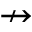<formula> <loc_0><loc_0><loc_500><loc_500>\nrightarrow</formula> 